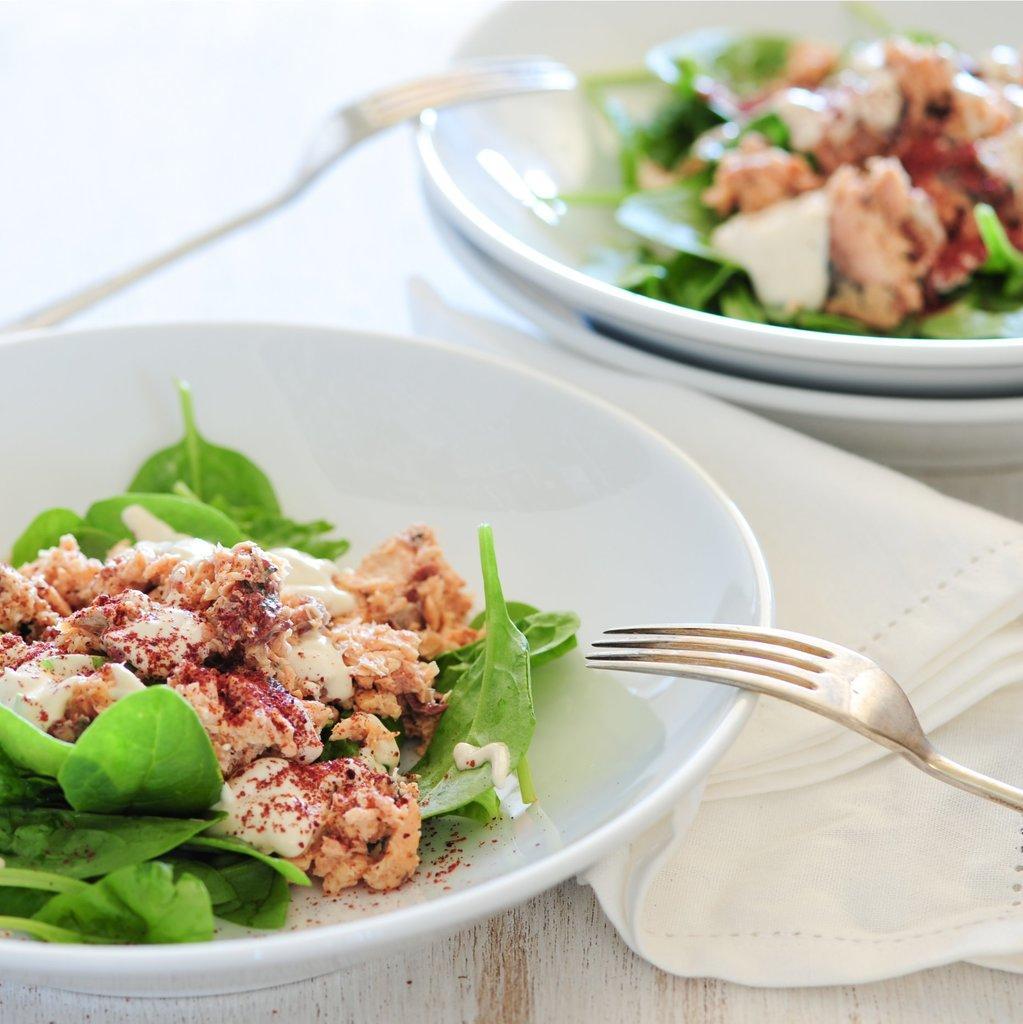Can you describe this image briefly? In this picture we can see plates,food items,forks and tissue papers. These all are placed on a platform. 